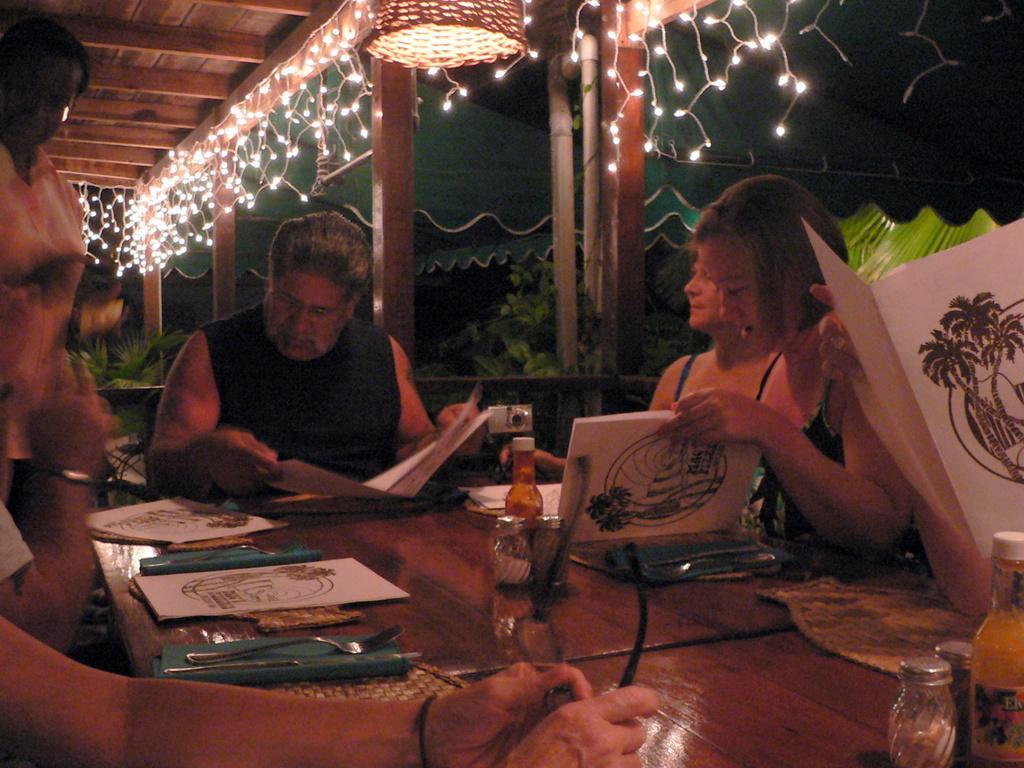Can you describe this image briefly? In this picture there are group of people sitting on a chair in a dining in front of the dining table. The man in the center is holding a paper in his hand. The woman at the right side is holding a menu card in her hand. On the table there bottles, paper, spoon, fork. In the background there are lights hanging, trees and a green colour tent. 